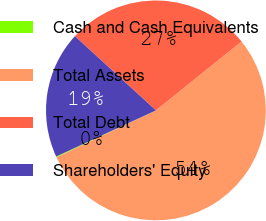<chart> <loc_0><loc_0><loc_500><loc_500><pie_chart><fcel>Cash and Cash Equivalents<fcel>Total Assets<fcel>Total Debt<fcel>Shareholders' Equity<nl><fcel>0.13%<fcel>53.77%<fcel>27.4%<fcel>18.7%<nl></chart> 